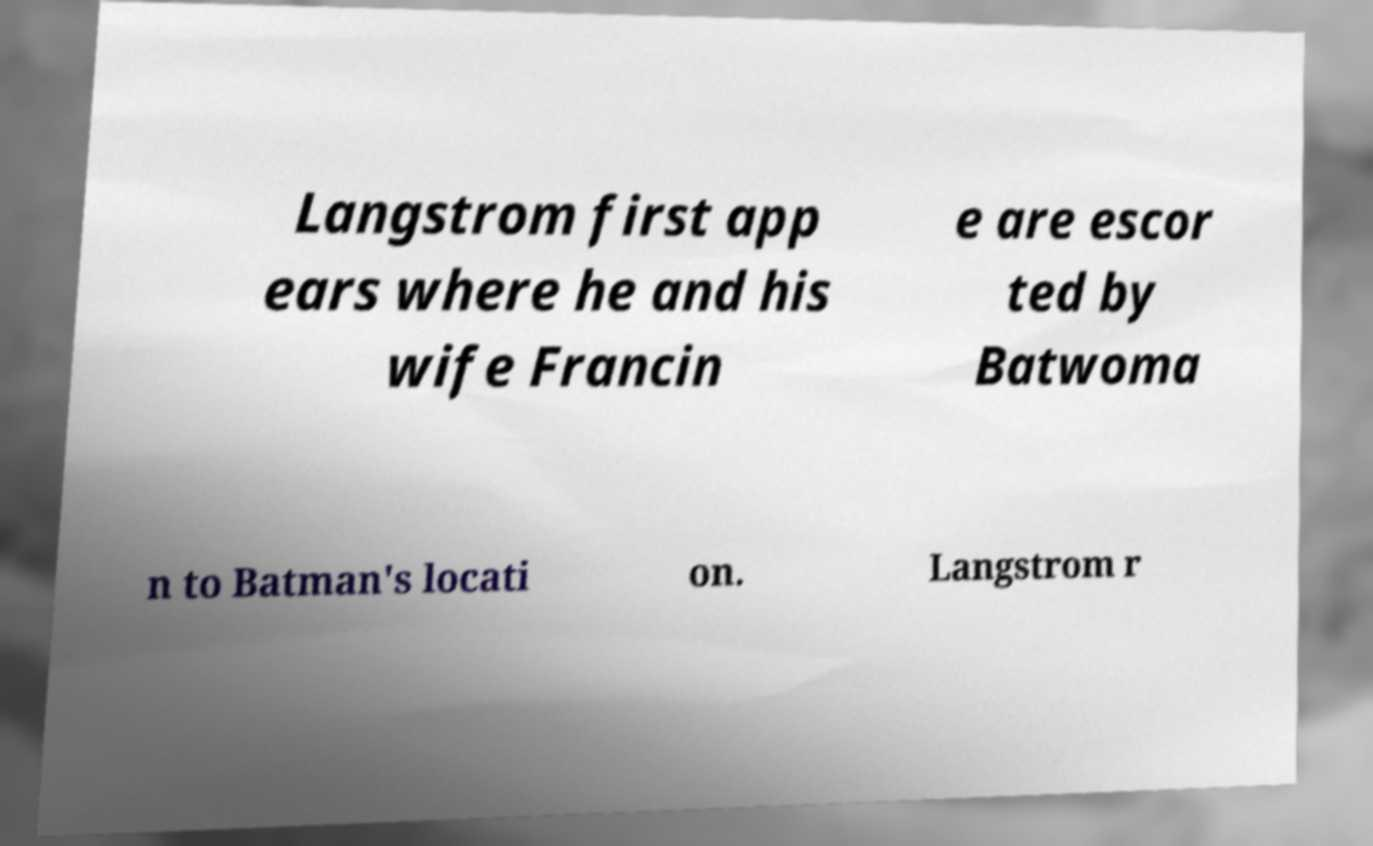I need the written content from this picture converted into text. Can you do that? Langstrom first app ears where he and his wife Francin e are escor ted by Batwoma n to Batman's locati on. Langstrom r 